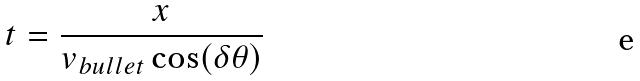Convert formula to latex. <formula><loc_0><loc_0><loc_500><loc_500>t = \frac { x } { v _ { b u l l e t } \cos ( \delta \theta ) }</formula> 